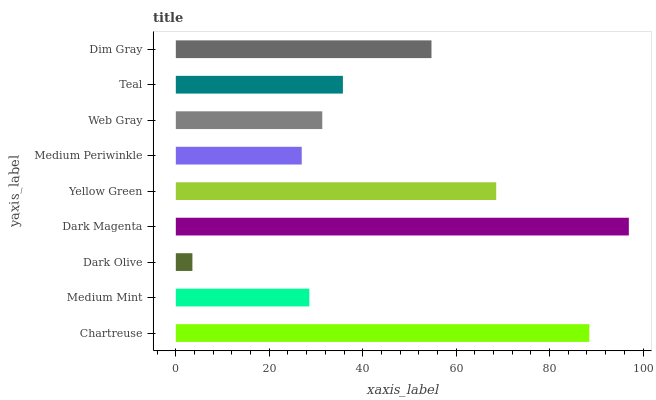Is Dark Olive the minimum?
Answer yes or no. Yes. Is Dark Magenta the maximum?
Answer yes or no. Yes. Is Medium Mint the minimum?
Answer yes or no. No. Is Medium Mint the maximum?
Answer yes or no. No. Is Chartreuse greater than Medium Mint?
Answer yes or no. Yes. Is Medium Mint less than Chartreuse?
Answer yes or no. Yes. Is Medium Mint greater than Chartreuse?
Answer yes or no. No. Is Chartreuse less than Medium Mint?
Answer yes or no. No. Is Teal the high median?
Answer yes or no. Yes. Is Teal the low median?
Answer yes or no. Yes. Is Chartreuse the high median?
Answer yes or no. No. Is Medium Periwinkle the low median?
Answer yes or no. No. 